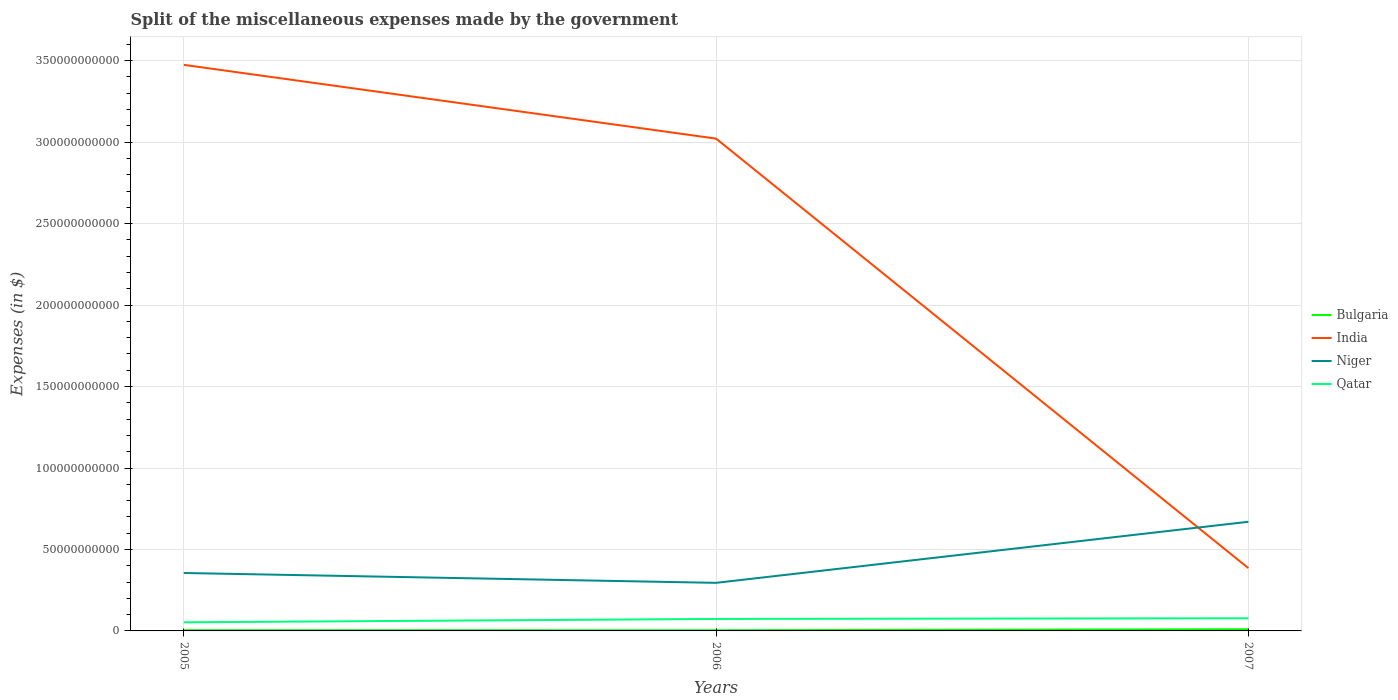How many different coloured lines are there?
Your answer should be very brief. 4. Is the number of lines equal to the number of legend labels?
Make the answer very short. Yes. Across all years, what is the maximum miscellaneous expenses made by the government in Bulgaria?
Ensure brevity in your answer.  4.12e+08. In which year was the miscellaneous expenses made by the government in Niger maximum?
Keep it short and to the point. 2006. What is the total miscellaneous expenses made by the government in Niger in the graph?
Make the answer very short. 6.05e+09. What is the difference between the highest and the second highest miscellaneous expenses made by the government in India?
Ensure brevity in your answer.  3.09e+11. What is the difference between the highest and the lowest miscellaneous expenses made by the government in Qatar?
Your answer should be very brief. 2. How many lines are there?
Your response must be concise. 4. How many years are there in the graph?
Ensure brevity in your answer.  3. What is the difference between two consecutive major ticks on the Y-axis?
Provide a succinct answer. 5.00e+1. Are the values on the major ticks of Y-axis written in scientific E-notation?
Your answer should be compact. No. What is the title of the graph?
Offer a terse response. Split of the miscellaneous expenses made by the government. Does "South Sudan" appear as one of the legend labels in the graph?
Provide a succinct answer. No. What is the label or title of the X-axis?
Ensure brevity in your answer.  Years. What is the label or title of the Y-axis?
Ensure brevity in your answer.  Expenses (in $). What is the Expenses (in $) of Bulgaria in 2005?
Make the answer very short. 4.53e+08. What is the Expenses (in $) of India in 2005?
Your response must be concise. 3.47e+11. What is the Expenses (in $) of Niger in 2005?
Your answer should be very brief. 3.56e+1. What is the Expenses (in $) of Qatar in 2005?
Provide a succinct answer. 5.28e+09. What is the Expenses (in $) of Bulgaria in 2006?
Your response must be concise. 4.12e+08. What is the Expenses (in $) of India in 2006?
Ensure brevity in your answer.  3.02e+11. What is the Expenses (in $) of Niger in 2006?
Give a very brief answer. 2.95e+1. What is the Expenses (in $) in Qatar in 2006?
Your answer should be compact. 7.35e+09. What is the Expenses (in $) of Bulgaria in 2007?
Offer a terse response. 1.05e+09. What is the Expenses (in $) in India in 2007?
Your response must be concise. 3.86e+1. What is the Expenses (in $) in Niger in 2007?
Offer a terse response. 6.70e+1. What is the Expenses (in $) in Qatar in 2007?
Your answer should be compact. 7.78e+09. Across all years, what is the maximum Expenses (in $) in Bulgaria?
Offer a very short reply. 1.05e+09. Across all years, what is the maximum Expenses (in $) in India?
Your answer should be very brief. 3.47e+11. Across all years, what is the maximum Expenses (in $) of Niger?
Make the answer very short. 6.70e+1. Across all years, what is the maximum Expenses (in $) of Qatar?
Give a very brief answer. 7.78e+09. Across all years, what is the minimum Expenses (in $) in Bulgaria?
Your answer should be compact. 4.12e+08. Across all years, what is the minimum Expenses (in $) of India?
Give a very brief answer. 3.86e+1. Across all years, what is the minimum Expenses (in $) of Niger?
Make the answer very short. 2.95e+1. Across all years, what is the minimum Expenses (in $) of Qatar?
Keep it short and to the point. 5.28e+09. What is the total Expenses (in $) in Bulgaria in the graph?
Ensure brevity in your answer.  1.91e+09. What is the total Expenses (in $) in India in the graph?
Your answer should be very brief. 6.88e+11. What is the total Expenses (in $) of Niger in the graph?
Your answer should be very brief. 1.32e+11. What is the total Expenses (in $) in Qatar in the graph?
Your answer should be compact. 2.04e+1. What is the difference between the Expenses (in $) of Bulgaria in 2005 and that in 2006?
Keep it short and to the point. 4.15e+07. What is the difference between the Expenses (in $) of India in 2005 and that in 2006?
Your answer should be compact. 4.53e+1. What is the difference between the Expenses (in $) of Niger in 2005 and that in 2006?
Provide a short and direct response. 6.05e+09. What is the difference between the Expenses (in $) in Qatar in 2005 and that in 2006?
Keep it short and to the point. -2.07e+09. What is the difference between the Expenses (in $) of Bulgaria in 2005 and that in 2007?
Your answer should be compact. -5.95e+08. What is the difference between the Expenses (in $) of India in 2005 and that in 2007?
Your response must be concise. 3.09e+11. What is the difference between the Expenses (in $) in Niger in 2005 and that in 2007?
Provide a short and direct response. -3.14e+1. What is the difference between the Expenses (in $) in Qatar in 2005 and that in 2007?
Give a very brief answer. -2.50e+09. What is the difference between the Expenses (in $) of Bulgaria in 2006 and that in 2007?
Provide a short and direct response. -6.37e+08. What is the difference between the Expenses (in $) of India in 2006 and that in 2007?
Your answer should be very brief. 2.64e+11. What is the difference between the Expenses (in $) of Niger in 2006 and that in 2007?
Offer a terse response. -3.75e+1. What is the difference between the Expenses (in $) in Qatar in 2006 and that in 2007?
Offer a terse response. -4.29e+08. What is the difference between the Expenses (in $) in Bulgaria in 2005 and the Expenses (in $) in India in 2006?
Offer a very short reply. -3.02e+11. What is the difference between the Expenses (in $) in Bulgaria in 2005 and the Expenses (in $) in Niger in 2006?
Offer a terse response. -2.91e+1. What is the difference between the Expenses (in $) in Bulgaria in 2005 and the Expenses (in $) in Qatar in 2006?
Provide a short and direct response. -6.90e+09. What is the difference between the Expenses (in $) of India in 2005 and the Expenses (in $) of Niger in 2006?
Ensure brevity in your answer.  3.18e+11. What is the difference between the Expenses (in $) of India in 2005 and the Expenses (in $) of Qatar in 2006?
Your answer should be compact. 3.40e+11. What is the difference between the Expenses (in $) in Niger in 2005 and the Expenses (in $) in Qatar in 2006?
Your answer should be very brief. 2.82e+1. What is the difference between the Expenses (in $) of Bulgaria in 2005 and the Expenses (in $) of India in 2007?
Your response must be concise. -3.81e+1. What is the difference between the Expenses (in $) of Bulgaria in 2005 and the Expenses (in $) of Niger in 2007?
Your answer should be compact. -6.65e+1. What is the difference between the Expenses (in $) of Bulgaria in 2005 and the Expenses (in $) of Qatar in 2007?
Give a very brief answer. -7.33e+09. What is the difference between the Expenses (in $) in India in 2005 and the Expenses (in $) in Niger in 2007?
Ensure brevity in your answer.  2.80e+11. What is the difference between the Expenses (in $) in India in 2005 and the Expenses (in $) in Qatar in 2007?
Your answer should be very brief. 3.40e+11. What is the difference between the Expenses (in $) of Niger in 2005 and the Expenses (in $) of Qatar in 2007?
Give a very brief answer. 2.78e+1. What is the difference between the Expenses (in $) in Bulgaria in 2006 and the Expenses (in $) in India in 2007?
Your answer should be compact. -3.81e+1. What is the difference between the Expenses (in $) in Bulgaria in 2006 and the Expenses (in $) in Niger in 2007?
Offer a terse response. -6.66e+1. What is the difference between the Expenses (in $) of Bulgaria in 2006 and the Expenses (in $) of Qatar in 2007?
Offer a very short reply. -7.37e+09. What is the difference between the Expenses (in $) in India in 2006 and the Expenses (in $) in Niger in 2007?
Your answer should be compact. 2.35e+11. What is the difference between the Expenses (in $) in India in 2006 and the Expenses (in $) in Qatar in 2007?
Offer a terse response. 2.94e+11. What is the difference between the Expenses (in $) of Niger in 2006 and the Expenses (in $) of Qatar in 2007?
Ensure brevity in your answer.  2.17e+1. What is the average Expenses (in $) of Bulgaria per year?
Ensure brevity in your answer.  6.38e+08. What is the average Expenses (in $) of India per year?
Keep it short and to the point. 2.29e+11. What is the average Expenses (in $) of Niger per year?
Your answer should be very brief. 4.40e+1. What is the average Expenses (in $) in Qatar per year?
Provide a short and direct response. 6.80e+09. In the year 2005, what is the difference between the Expenses (in $) in Bulgaria and Expenses (in $) in India?
Ensure brevity in your answer.  -3.47e+11. In the year 2005, what is the difference between the Expenses (in $) of Bulgaria and Expenses (in $) of Niger?
Make the answer very short. -3.51e+1. In the year 2005, what is the difference between the Expenses (in $) in Bulgaria and Expenses (in $) in Qatar?
Your response must be concise. -4.83e+09. In the year 2005, what is the difference between the Expenses (in $) in India and Expenses (in $) in Niger?
Provide a short and direct response. 3.12e+11. In the year 2005, what is the difference between the Expenses (in $) in India and Expenses (in $) in Qatar?
Your response must be concise. 3.42e+11. In the year 2005, what is the difference between the Expenses (in $) in Niger and Expenses (in $) in Qatar?
Keep it short and to the point. 3.03e+1. In the year 2006, what is the difference between the Expenses (in $) in Bulgaria and Expenses (in $) in India?
Offer a very short reply. -3.02e+11. In the year 2006, what is the difference between the Expenses (in $) of Bulgaria and Expenses (in $) of Niger?
Your answer should be compact. -2.91e+1. In the year 2006, what is the difference between the Expenses (in $) of Bulgaria and Expenses (in $) of Qatar?
Your answer should be compact. -6.94e+09. In the year 2006, what is the difference between the Expenses (in $) of India and Expenses (in $) of Niger?
Make the answer very short. 2.73e+11. In the year 2006, what is the difference between the Expenses (in $) in India and Expenses (in $) in Qatar?
Give a very brief answer. 2.95e+11. In the year 2006, what is the difference between the Expenses (in $) in Niger and Expenses (in $) in Qatar?
Make the answer very short. 2.22e+1. In the year 2007, what is the difference between the Expenses (in $) of Bulgaria and Expenses (in $) of India?
Your response must be concise. -3.75e+1. In the year 2007, what is the difference between the Expenses (in $) of Bulgaria and Expenses (in $) of Niger?
Provide a succinct answer. -6.59e+1. In the year 2007, what is the difference between the Expenses (in $) in Bulgaria and Expenses (in $) in Qatar?
Ensure brevity in your answer.  -6.73e+09. In the year 2007, what is the difference between the Expenses (in $) of India and Expenses (in $) of Niger?
Make the answer very short. -2.84e+1. In the year 2007, what is the difference between the Expenses (in $) in India and Expenses (in $) in Qatar?
Make the answer very short. 3.08e+1. In the year 2007, what is the difference between the Expenses (in $) in Niger and Expenses (in $) in Qatar?
Your response must be concise. 5.92e+1. What is the ratio of the Expenses (in $) in Bulgaria in 2005 to that in 2006?
Offer a terse response. 1.1. What is the ratio of the Expenses (in $) of India in 2005 to that in 2006?
Offer a very short reply. 1.15. What is the ratio of the Expenses (in $) in Niger in 2005 to that in 2006?
Make the answer very short. 1.2. What is the ratio of the Expenses (in $) in Qatar in 2005 to that in 2006?
Offer a terse response. 0.72. What is the ratio of the Expenses (in $) of Bulgaria in 2005 to that in 2007?
Make the answer very short. 0.43. What is the ratio of the Expenses (in $) in India in 2005 to that in 2007?
Provide a short and direct response. 9.01. What is the ratio of the Expenses (in $) of Niger in 2005 to that in 2007?
Ensure brevity in your answer.  0.53. What is the ratio of the Expenses (in $) of Qatar in 2005 to that in 2007?
Provide a short and direct response. 0.68. What is the ratio of the Expenses (in $) in Bulgaria in 2006 to that in 2007?
Ensure brevity in your answer.  0.39. What is the ratio of the Expenses (in $) of India in 2006 to that in 2007?
Your response must be concise. 7.84. What is the ratio of the Expenses (in $) of Niger in 2006 to that in 2007?
Provide a succinct answer. 0.44. What is the ratio of the Expenses (in $) in Qatar in 2006 to that in 2007?
Your answer should be very brief. 0.94. What is the difference between the highest and the second highest Expenses (in $) of Bulgaria?
Offer a very short reply. 5.95e+08. What is the difference between the highest and the second highest Expenses (in $) in India?
Offer a terse response. 4.53e+1. What is the difference between the highest and the second highest Expenses (in $) in Niger?
Your answer should be very brief. 3.14e+1. What is the difference between the highest and the second highest Expenses (in $) in Qatar?
Your response must be concise. 4.29e+08. What is the difference between the highest and the lowest Expenses (in $) of Bulgaria?
Provide a succinct answer. 6.37e+08. What is the difference between the highest and the lowest Expenses (in $) of India?
Your response must be concise. 3.09e+11. What is the difference between the highest and the lowest Expenses (in $) of Niger?
Provide a short and direct response. 3.75e+1. What is the difference between the highest and the lowest Expenses (in $) in Qatar?
Your answer should be compact. 2.50e+09. 